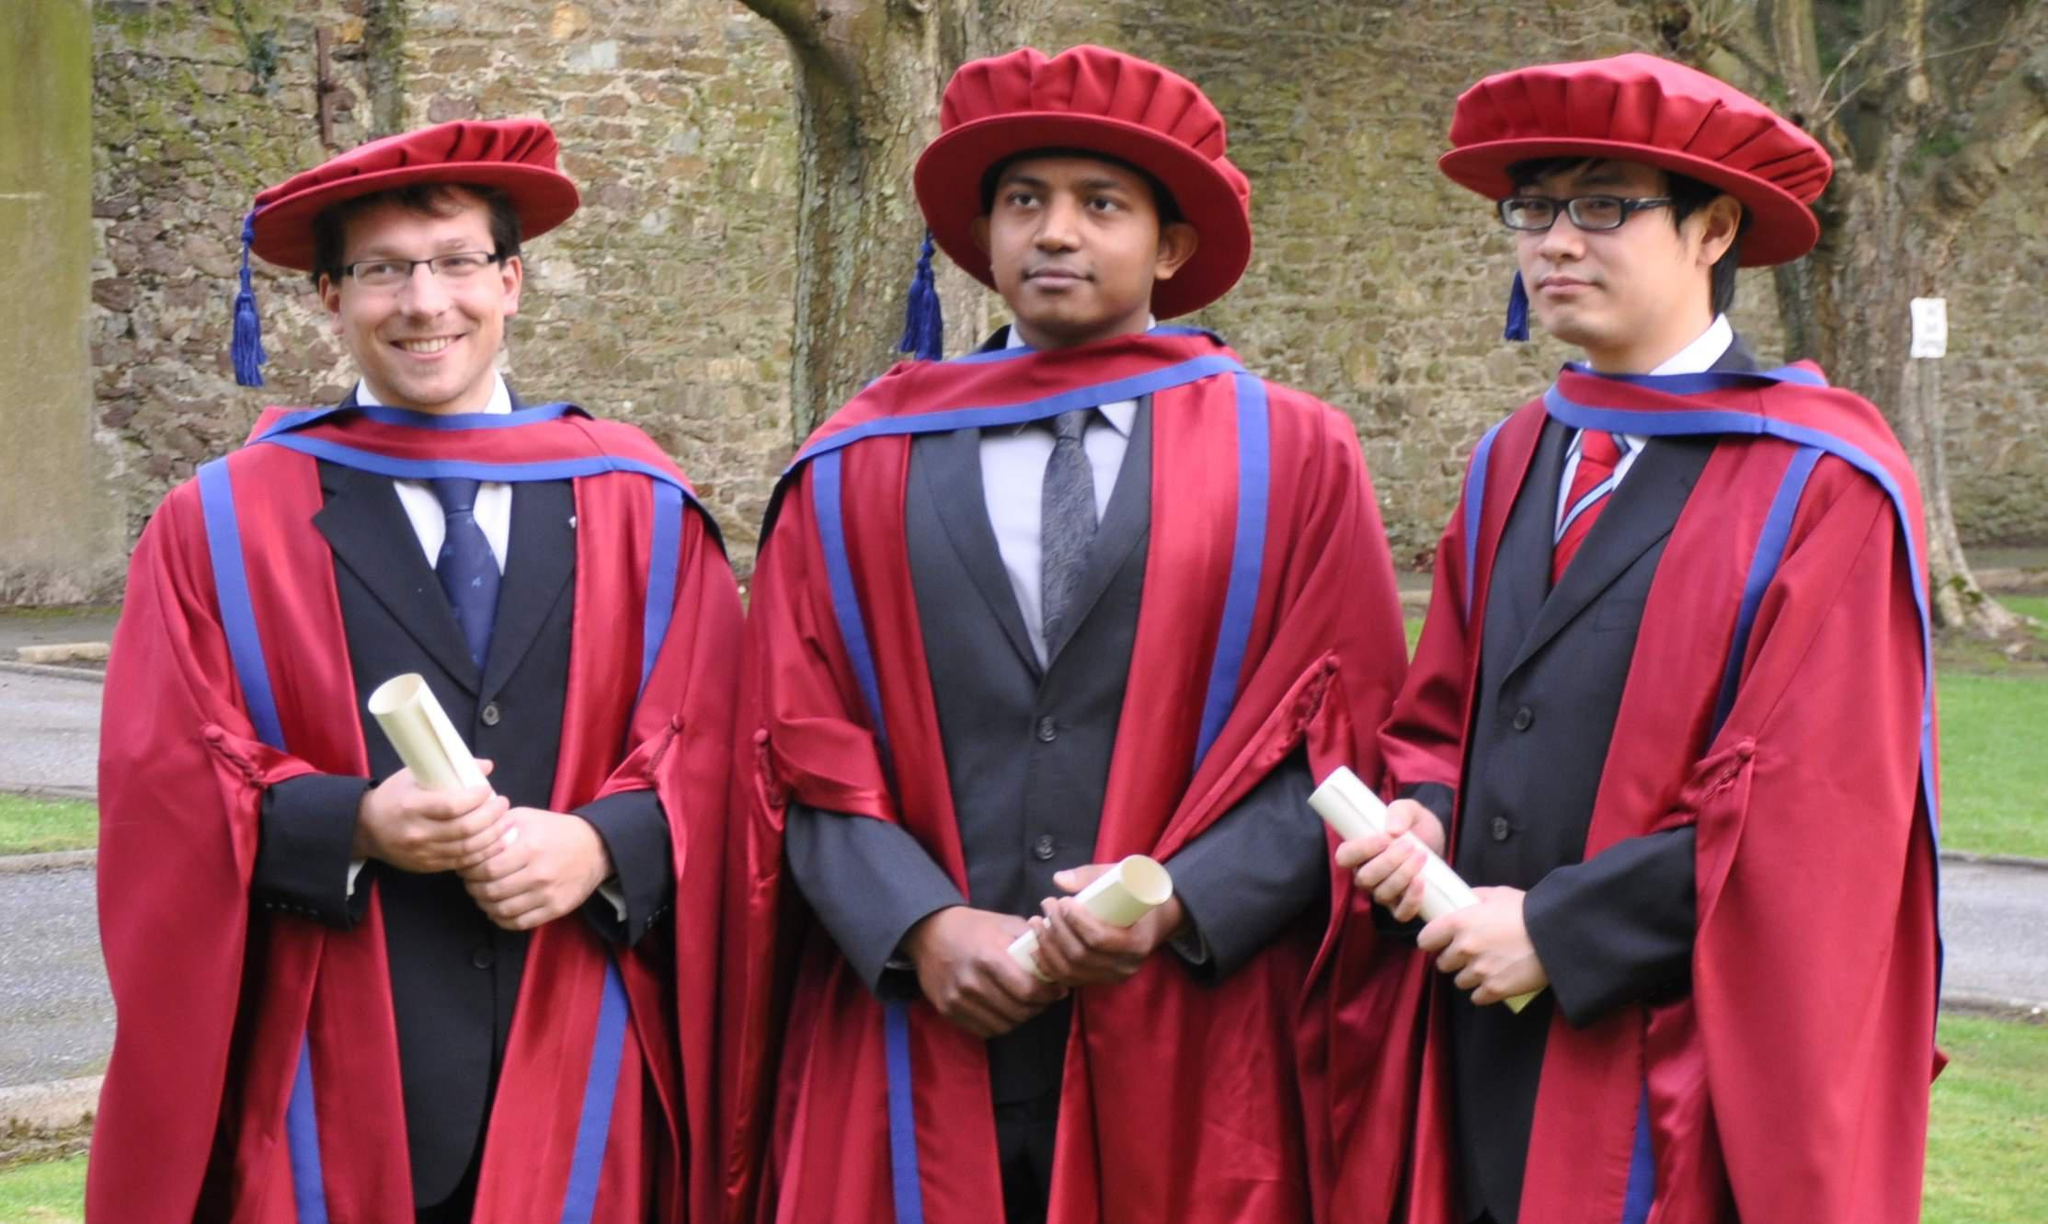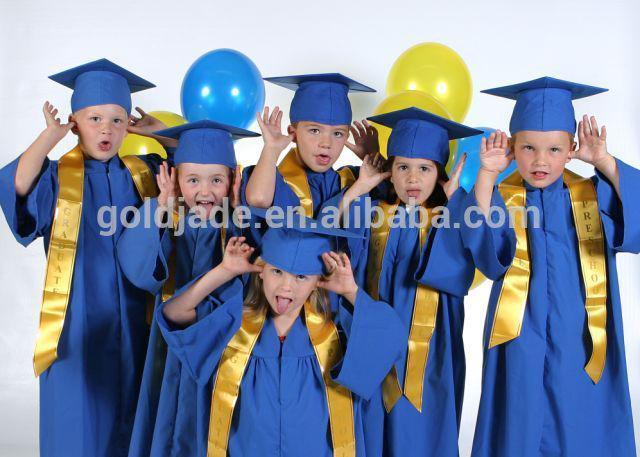The first image is the image on the left, the second image is the image on the right. For the images displayed, is the sentence "The left image contains exactly four children modeling four different colored graduation robes with matching hats, and two of them hold rolled white diplomas." factually correct? Answer yes or no. No. The first image is the image on the left, the second image is the image on the right. Examine the images to the left and right. Is the description "At least one person is wearing a white gown." accurate? Answer yes or no. No. 